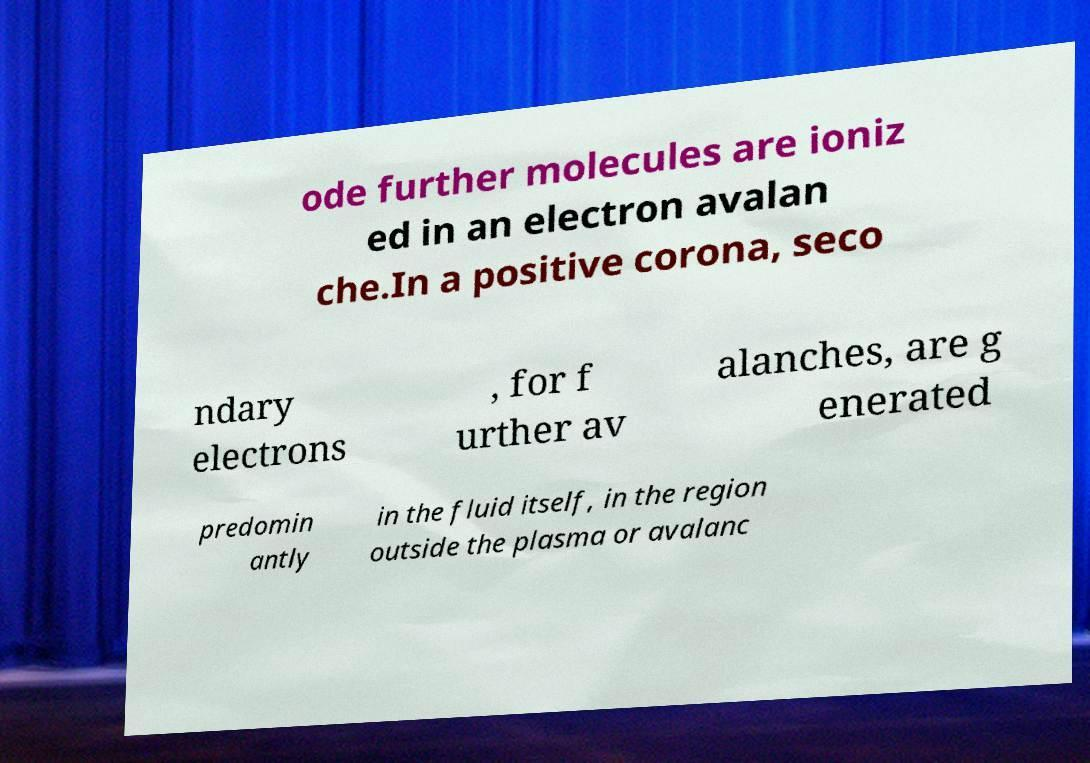I need the written content from this picture converted into text. Can you do that? ode further molecules are ioniz ed in an electron avalan che.In a positive corona, seco ndary electrons , for f urther av alanches, are g enerated predomin antly in the fluid itself, in the region outside the plasma or avalanc 